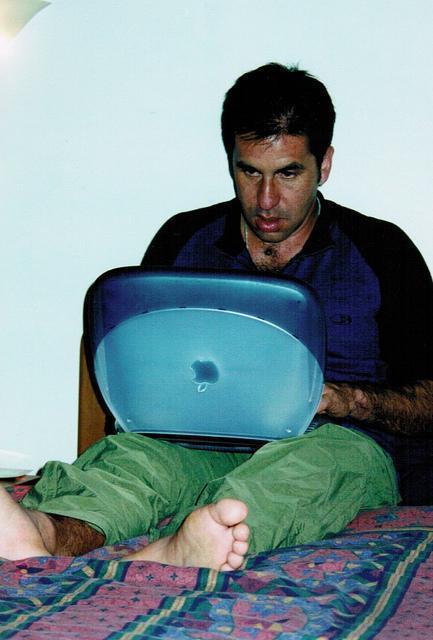What font is used in Apple logo?
Select the accurate response from the four choices given to answer the question.
Options: Slab serif, sans, helvetica, serif. Helvetica. 